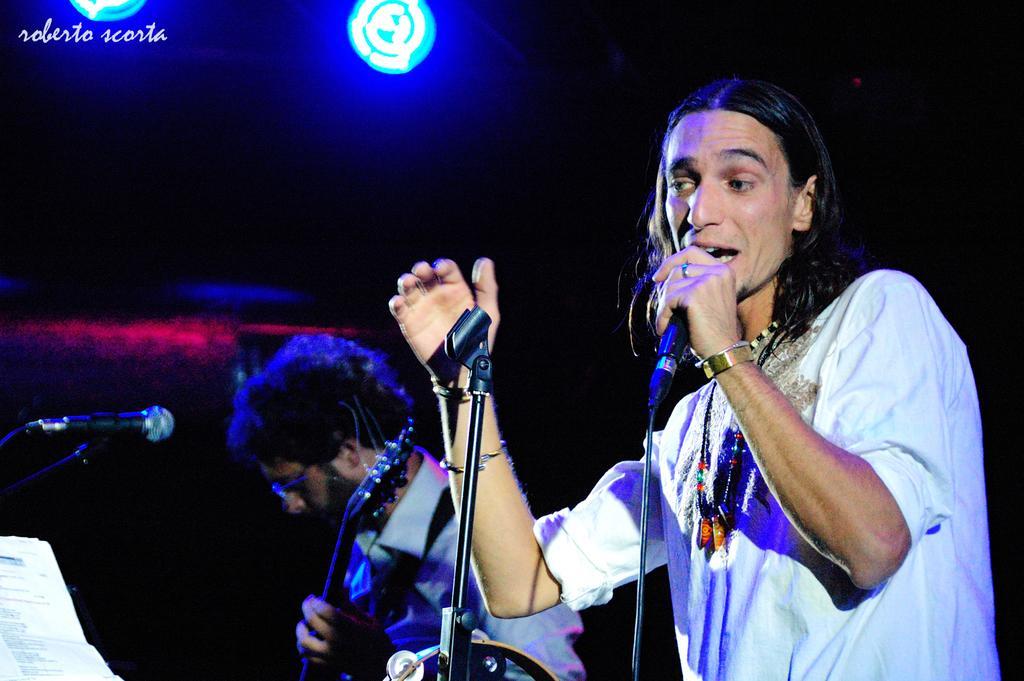Could you give a brief overview of what you see in this image? In this picture we can see a man holding a mike and singing. On the left side, we can see another man holding a guitar in his hands and standing in front of a mike. 